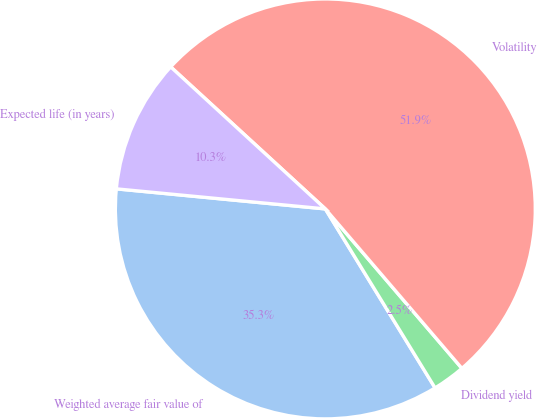<chart> <loc_0><loc_0><loc_500><loc_500><pie_chart><fcel>Weighted average fair value of<fcel>Dividend yield<fcel>Volatility<fcel>Expected life (in years)<nl><fcel>35.28%<fcel>2.52%<fcel>51.91%<fcel>10.3%<nl></chart> 